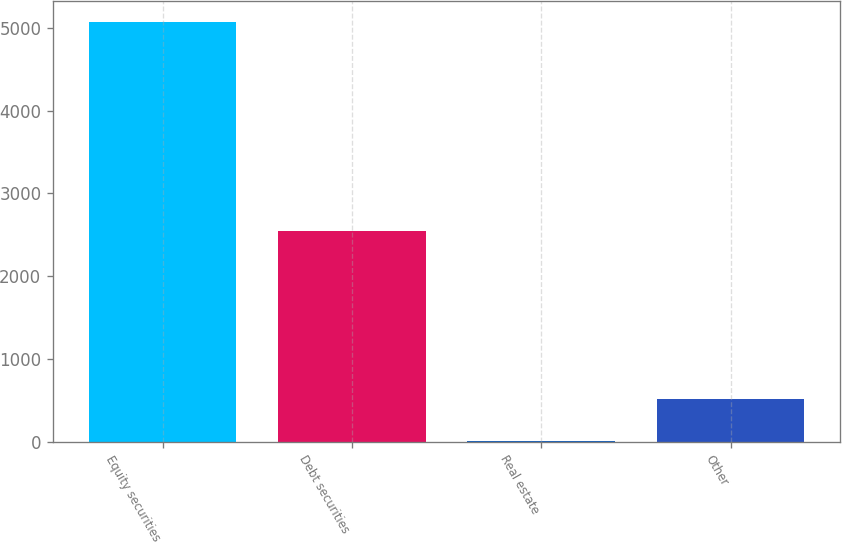<chart> <loc_0><loc_0><loc_500><loc_500><bar_chart><fcel>Equity securities<fcel>Debt securities<fcel>Real estate<fcel>Other<nl><fcel>5075<fcel>2550<fcel>10<fcel>516.5<nl></chart> 